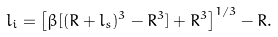<formula> <loc_0><loc_0><loc_500><loc_500>l _ { i } = \left [ \beta [ ( R + l _ { s } ) ^ { 3 } - R ^ { 3 } ] + R ^ { 3 } \right ] ^ { 1 / 3 } - R .</formula> 